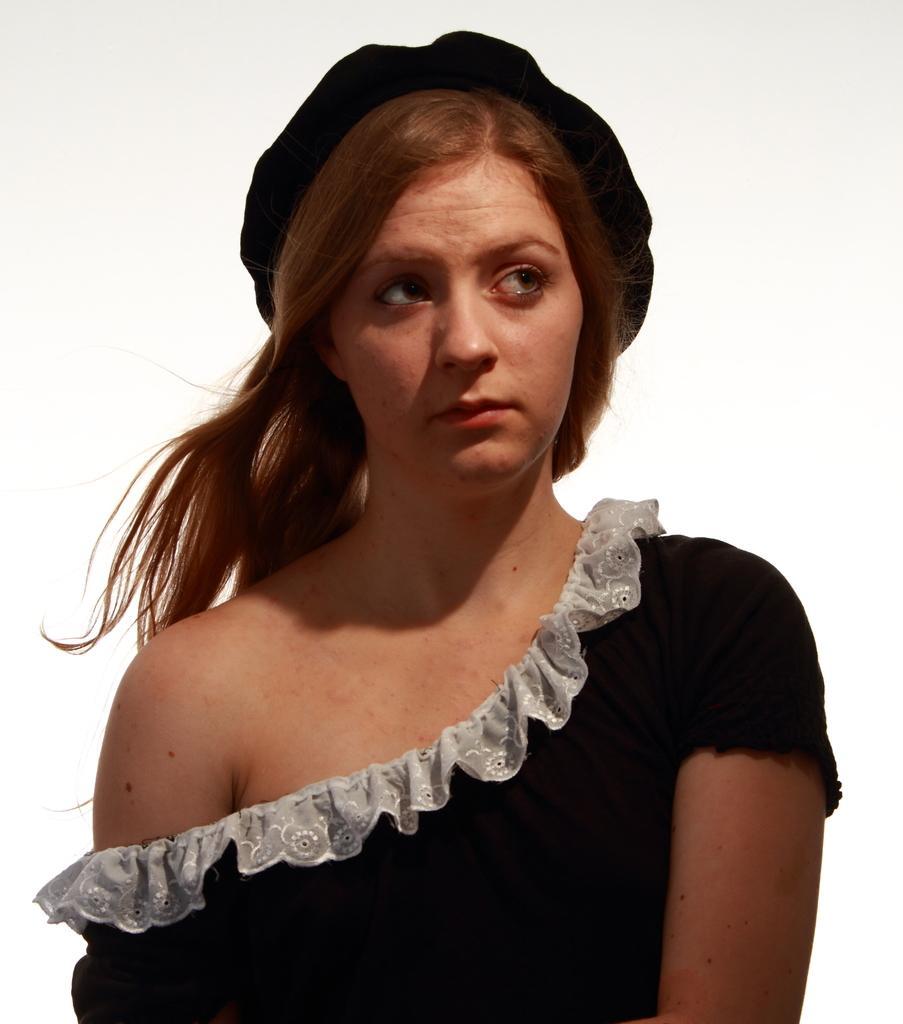Please provide a concise description of this image. This image consists of a woman and a white color background. This image is taken may be during a day. 